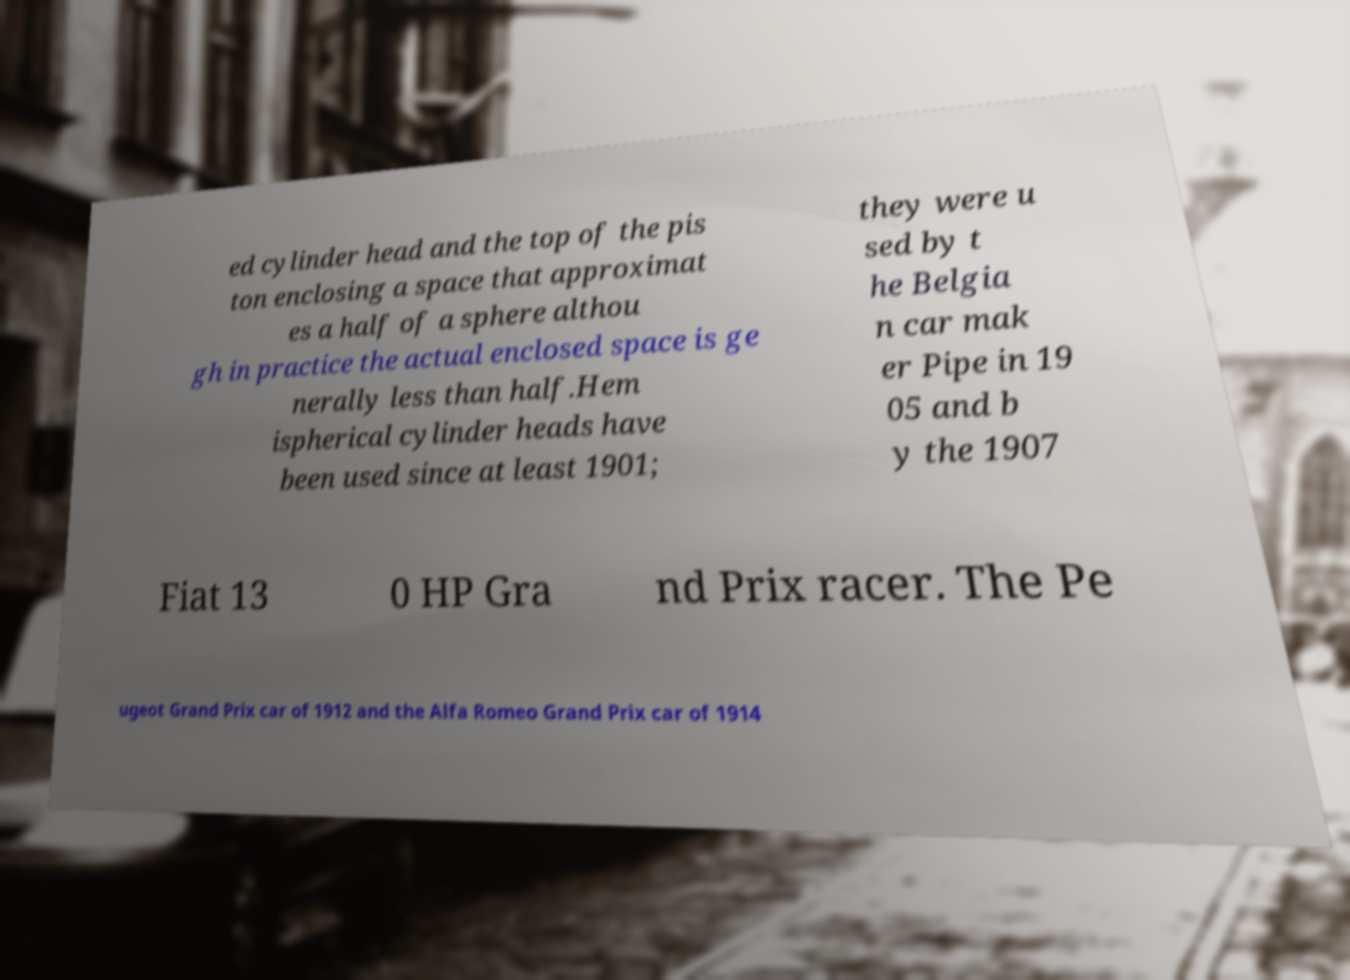Please identify and transcribe the text found in this image. ed cylinder head and the top of the pis ton enclosing a space that approximat es a half of a sphere althou gh in practice the actual enclosed space is ge nerally less than half.Hem ispherical cylinder heads have been used since at least 1901; they were u sed by t he Belgia n car mak er Pipe in 19 05 and b y the 1907 Fiat 13 0 HP Gra nd Prix racer. The Pe ugeot Grand Prix car of 1912 and the Alfa Romeo Grand Prix car of 1914 